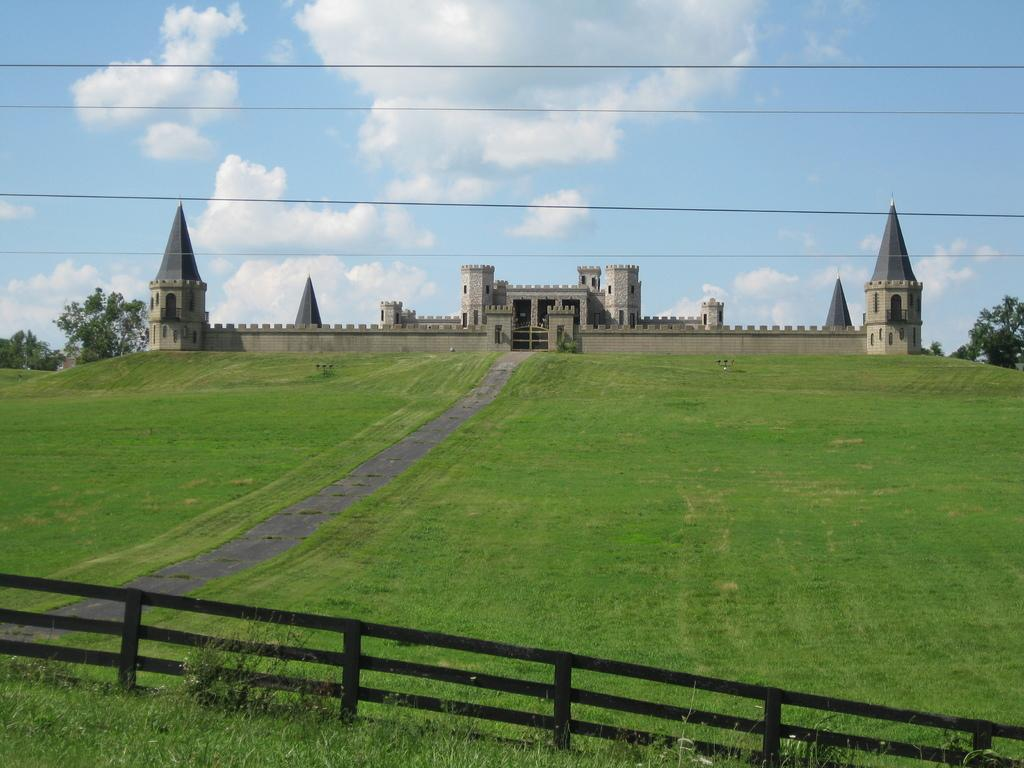What type of structure can be seen in the backdrop of the image? There is a fort in the backdrop of the image. What is the terrain like in the image? There is grass and plants visible in the image. What type of pathway is present in the image? There is a walkway in the image. What type of barrier is present in the image? There is a fence in the image. What is the condition of the sky in the image? The sky is clear in the image. Where is the market located in the image? There is no market present in the image. What type of shelter is set up in the image? There is no tent or any other type of shelter present in the image. 